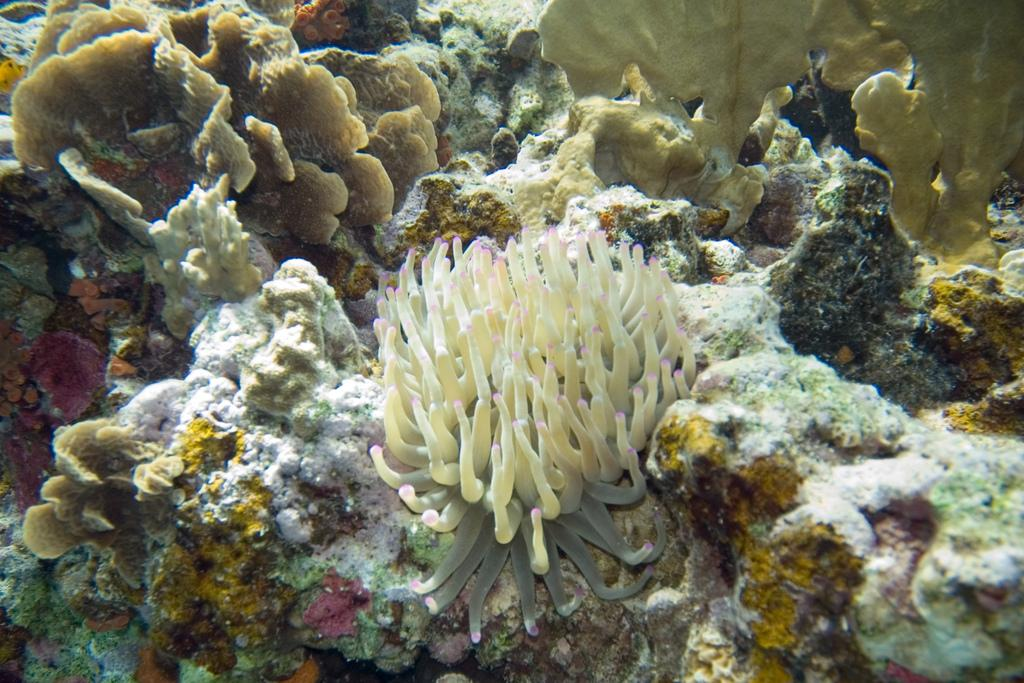What type of environment is depicted in the image? The image is an underwater scene. What types of vegetation can be seen in the image? There are aquatic plants in the image. What other objects are present in the underwater environment? There are rocks in the image. What type of belief system is being practiced by the fish in the image? There are no fish or any indication of a belief system in the image; it is an underwater scene with aquatic plants and rocks. 